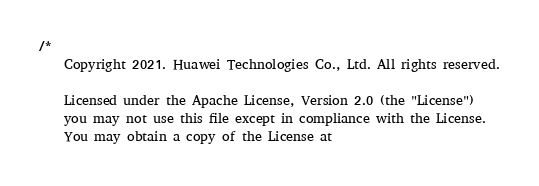<code> <loc_0><loc_0><loc_500><loc_500><_Dart_>/*
    Copyright 2021. Huawei Technologies Co., Ltd. All rights reserved.

    Licensed under the Apache License, Version 2.0 (the "License")
    you may not use this file except in compliance with the License.
    You may obtain a copy of the License at
</code> 